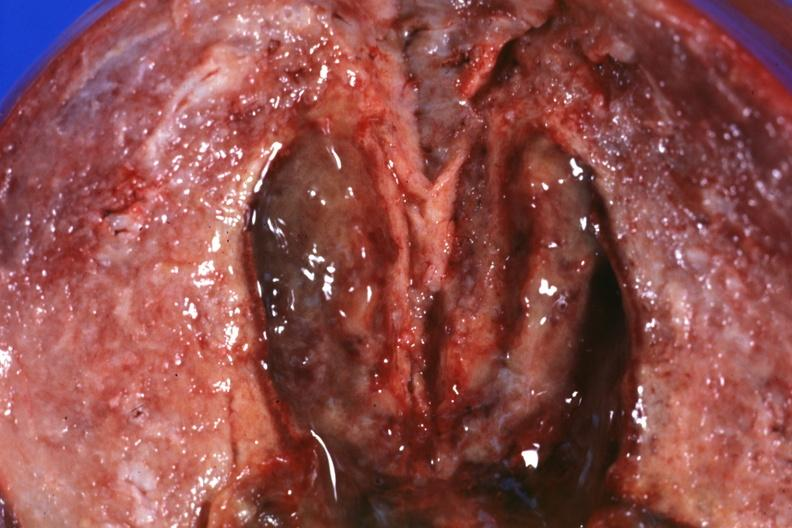s all the fat necrosis present?
Answer the question using a single word or phrase. No 